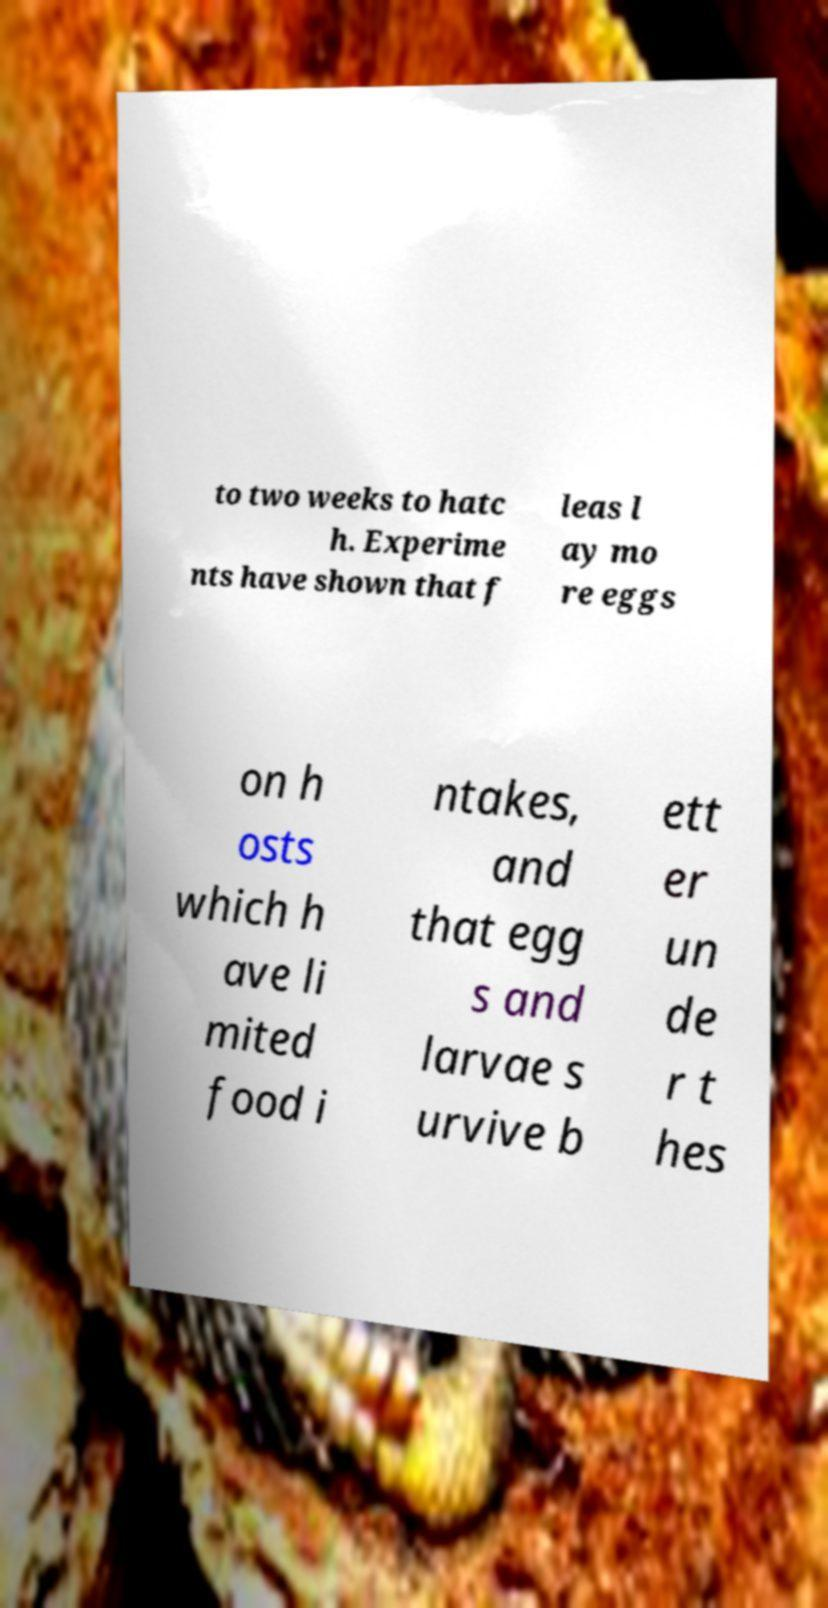For documentation purposes, I need the text within this image transcribed. Could you provide that? to two weeks to hatc h. Experime nts have shown that f leas l ay mo re eggs on h osts which h ave li mited food i ntakes, and that egg s and larvae s urvive b ett er un de r t hes 